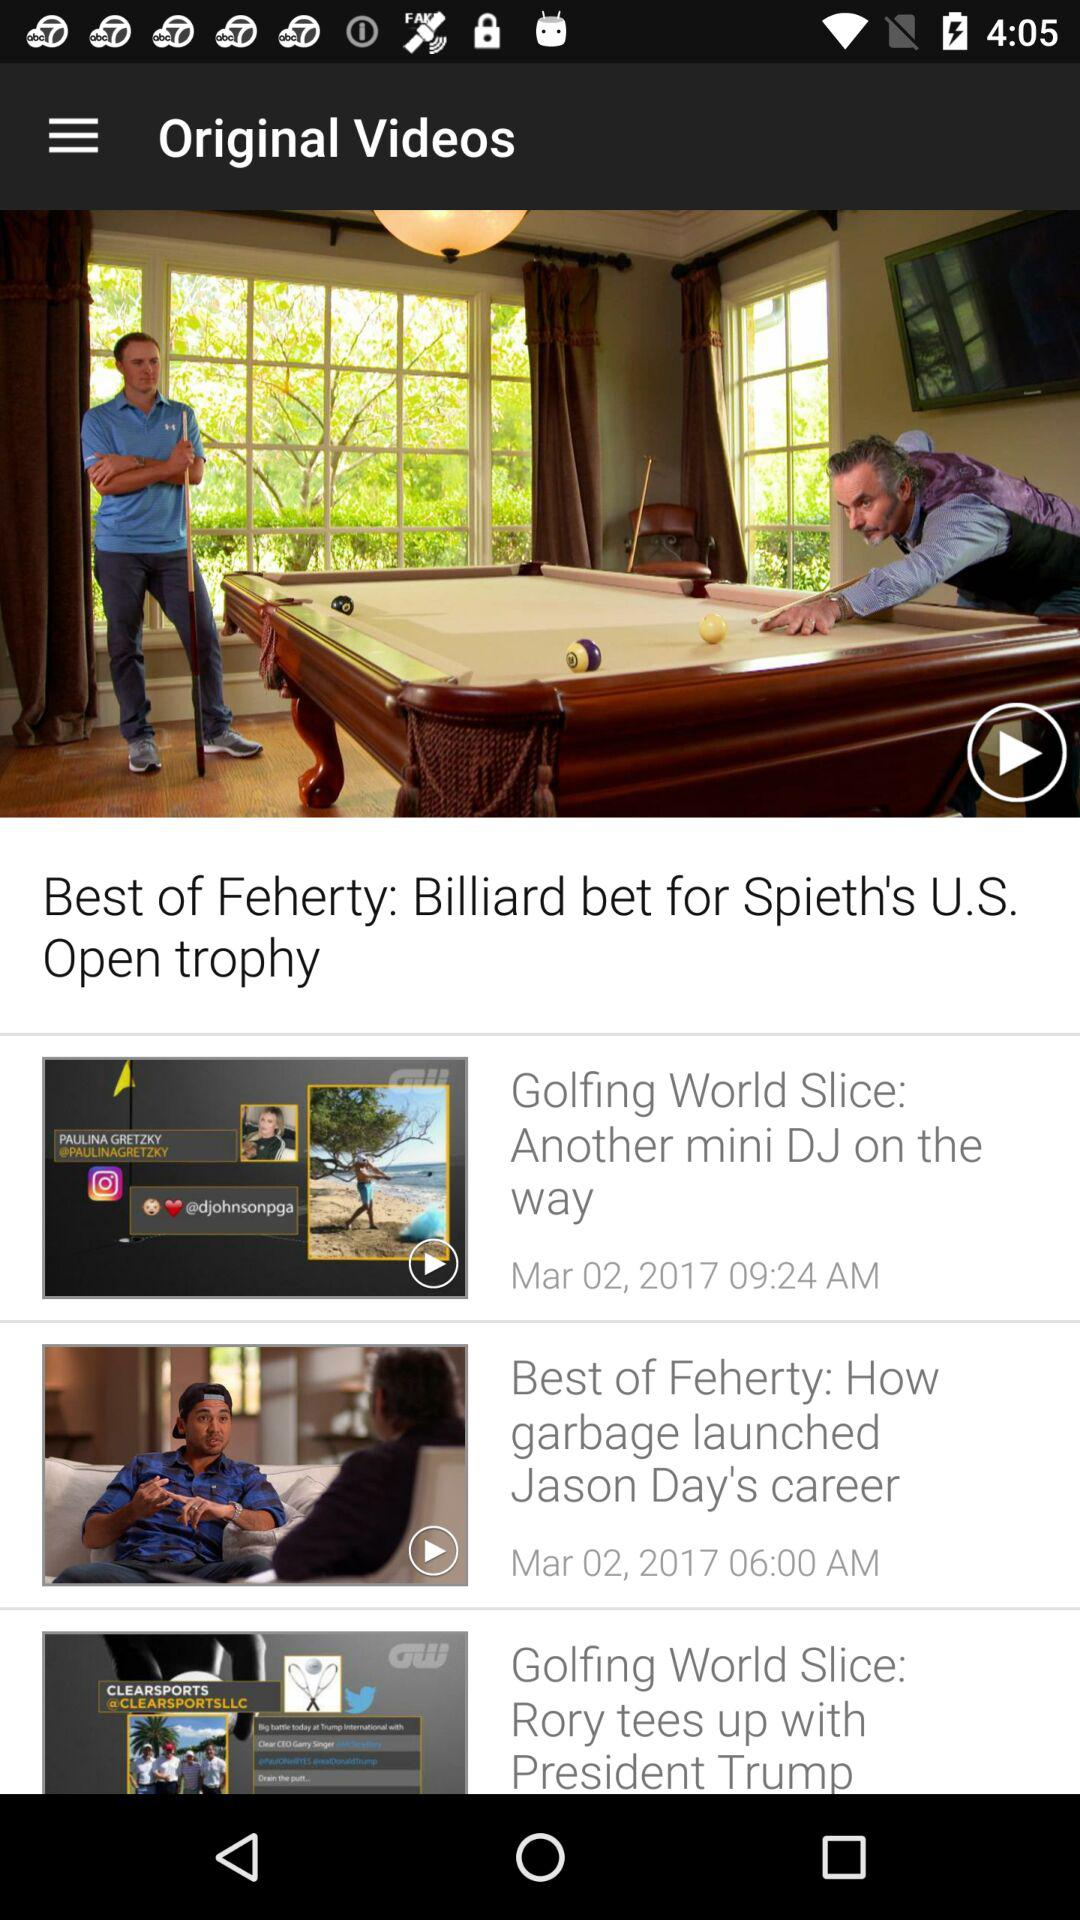What is the name of the video broadcasted on March 2, 2017 at 9:24 a.m.? The video broadcasted on March 2, 2017 at 9:24 a.m. is "Golfing World Slice: Another mini DJ on the way". 